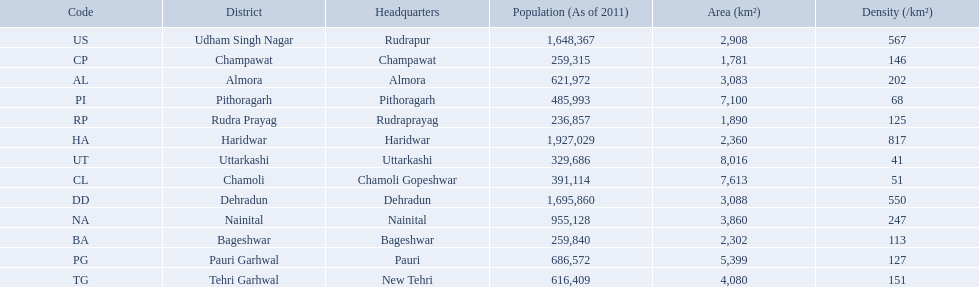What are the values for density of the districts of uttrakhand? 202, 113, 51, 146, 550, 817, 247, 127, 68, 125, 151, 567, 41. Can you give me this table in json format? {'header': ['Code', 'District', 'Headquarters', 'Population (As of 2011)', 'Area (km²)', 'Density (/km²)'], 'rows': [['US', 'Udham Singh Nagar', 'Rudrapur', '1,648,367', '2,908', '567'], ['CP', 'Champawat', 'Champawat', '259,315', '1,781', '146'], ['AL', 'Almora', 'Almora', '621,972', '3,083', '202'], ['PI', 'Pithoragarh', 'Pithoragarh', '485,993', '7,100', '68'], ['RP', 'Rudra Prayag', 'Rudraprayag', '236,857', '1,890', '125'], ['HA', 'Haridwar', 'Haridwar', '1,927,029', '2,360', '817'], ['UT', 'Uttarkashi', 'Uttarkashi', '329,686', '8,016', '41'], ['CL', 'Chamoli', 'Chamoli Gopeshwar', '391,114', '7,613', '51'], ['DD', 'Dehradun', 'Dehradun', '1,695,860', '3,088', '550'], ['NA', 'Nainital', 'Nainital', '955,128', '3,860', '247'], ['BA', 'Bageshwar', 'Bageshwar', '259,840', '2,302', '113'], ['PG', 'Pauri Garhwal', 'Pauri', '686,572', '5,399', '127'], ['TG', 'Tehri Garhwal', 'New Tehri', '616,409', '4,080', '151']]} Which district has value of 51? Chamoli. 